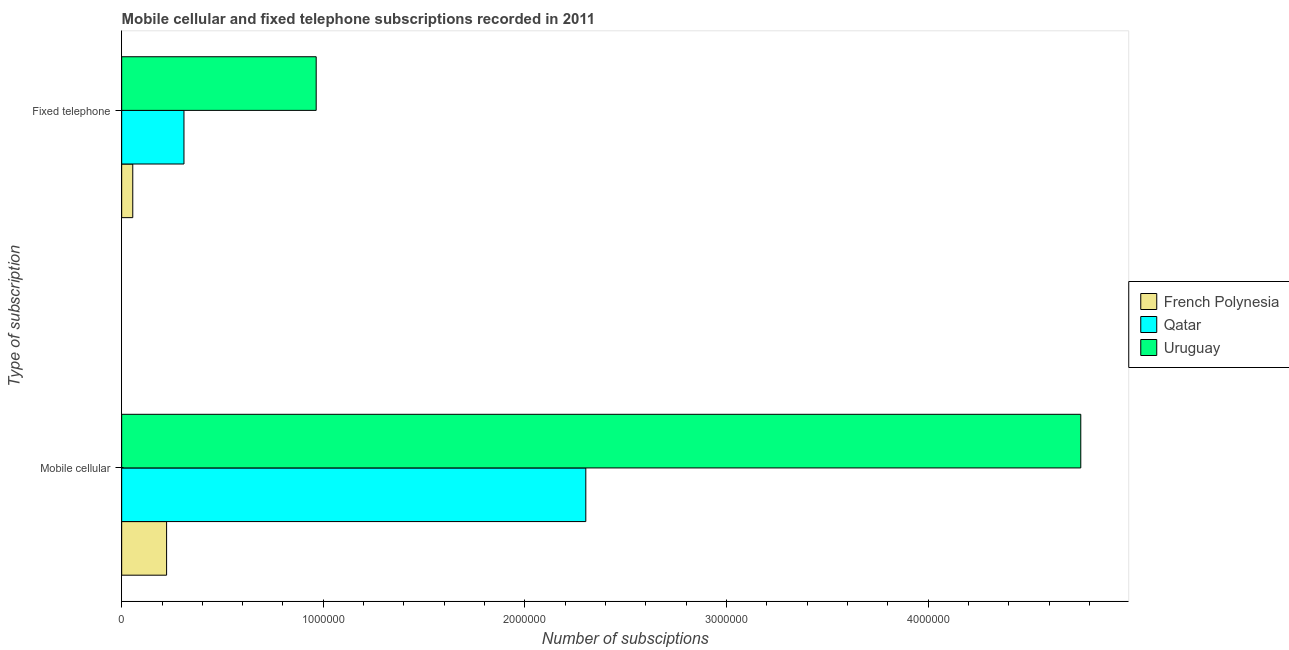How many different coloured bars are there?
Keep it short and to the point. 3. How many groups of bars are there?
Provide a short and direct response. 2. Are the number of bars per tick equal to the number of legend labels?
Provide a short and direct response. Yes. Are the number of bars on each tick of the Y-axis equal?
Offer a very short reply. Yes. How many bars are there on the 1st tick from the top?
Offer a terse response. 3. How many bars are there on the 1st tick from the bottom?
Ensure brevity in your answer.  3. What is the label of the 2nd group of bars from the top?
Your answer should be very brief. Mobile cellular. What is the number of fixed telephone subscriptions in French Polynesia?
Your answer should be compact. 5.50e+04. Across all countries, what is the maximum number of fixed telephone subscriptions?
Offer a terse response. 9.65e+05. Across all countries, what is the minimum number of fixed telephone subscriptions?
Offer a terse response. 5.50e+04. In which country was the number of fixed telephone subscriptions maximum?
Your response must be concise. Uruguay. In which country was the number of mobile cellular subscriptions minimum?
Ensure brevity in your answer.  French Polynesia. What is the total number of mobile cellular subscriptions in the graph?
Offer a terse response. 7.28e+06. What is the difference between the number of mobile cellular subscriptions in French Polynesia and that in Uruguay?
Give a very brief answer. -4.53e+06. What is the difference between the number of fixed telephone subscriptions in French Polynesia and the number of mobile cellular subscriptions in Uruguay?
Make the answer very short. -4.70e+06. What is the average number of fixed telephone subscriptions per country?
Provide a succinct answer. 4.43e+05. What is the difference between the number of mobile cellular subscriptions and number of fixed telephone subscriptions in Qatar?
Make the answer very short. 1.99e+06. In how many countries, is the number of fixed telephone subscriptions greater than 2400000 ?
Offer a very short reply. 0. What is the ratio of the number of fixed telephone subscriptions in French Polynesia to that in Uruguay?
Keep it short and to the point. 0.06. What does the 2nd bar from the top in Mobile cellular represents?
Provide a succinct answer. Qatar. What does the 2nd bar from the bottom in Fixed telephone represents?
Offer a terse response. Qatar. How many bars are there?
Provide a succinct answer. 6. Are the values on the major ticks of X-axis written in scientific E-notation?
Your response must be concise. No. Does the graph contain any zero values?
Give a very brief answer. No. Where does the legend appear in the graph?
Your response must be concise. Center right. How many legend labels are there?
Provide a succinct answer. 3. How are the legend labels stacked?
Your response must be concise. Vertical. What is the title of the graph?
Your response must be concise. Mobile cellular and fixed telephone subscriptions recorded in 2011. Does "Djibouti" appear as one of the legend labels in the graph?
Provide a short and direct response. No. What is the label or title of the X-axis?
Provide a succinct answer. Number of subsciptions. What is the label or title of the Y-axis?
Give a very brief answer. Type of subscription. What is the Number of subsciptions in French Polynesia in Mobile cellular?
Your answer should be very brief. 2.23e+05. What is the Number of subsciptions of Qatar in Mobile cellular?
Offer a very short reply. 2.30e+06. What is the Number of subsciptions of Uruguay in Mobile cellular?
Your answer should be very brief. 4.76e+06. What is the Number of subsciptions in French Polynesia in Fixed telephone?
Keep it short and to the point. 5.50e+04. What is the Number of subsciptions of Qatar in Fixed telephone?
Make the answer very short. 3.09e+05. What is the Number of subsciptions in Uruguay in Fixed telephone?
Offer a terse response. 9.65e+05. Across all Type of subscription, what is the maximum Number of subsciptions of French Polynesia?
Offer a very short reply. 2.23e+05. Across all Type of subscription, what is the maximum Number of subsciptions of Qatar?
Make the answer very short. 2.30e+06. Across all Type of subscription, what is the maximum Number of subsciptions of Uruguay?
Offer a terse response. 4.76e+06. Across all Type of subscription, what is the minimum Number of subsciptions of French Polynesia?
Your answer should be very brief. 5.50e+04. Across all Type of subscription, what is the minimum Number of subsciptions of Qatar?
Offer a terse response. 3.09e+05. Across all Type of subscription, what is the minimum Number of subsciptions in Uruguay?
Your response must be concise. 9.65e+05. What is the total Number of subsciptions in French Polynesia in the graph?
Your response must be concise. 2.78e+05. What is the total Number of subsciptions in Qatar in the graph?
Make the answer very short. 2.61e+06. What is the total Number of subsciptions in Uruguay in the graph?
Your answer should be very brief. 5.72e+06. What is the difference between the Number of subsciptions of French Polynesia in Mobile cellular and that in Fixed telephone?
Provide a short and direct response. 1.68e+05. What is the difference between the Number of subsciptions in Qatar in Mobile cellular and that in Fixed telephone?
Your response must be concise. 1.99e+06. What is the difference between the Number of subsciptions of Uruguay in Mobile cellular and that in Fixed telephone?
Make the answer very short. 3.79e+06. What is the difference between the Number of subsciptions of French Polynesia in Mobile cellular and the Number of subsciptions of Qatar in Fixed telephone?
Offer a very short reply. -8.62e+04. What is the difference between the Number of subsciptions of French Polynesia in Mobile cellular and the Number of subsciptions of Uruguay in Fixed telephone?
Keep it short and to the point. -7.42e+05. What is the difference between the Number of subsciptions in Qatar in Mobile cellular and the Number of subsciptions in Uruguay in Fixed telephone?
Provide a short and direct response. 1.34e+06. What is the average Number of subsciptions in French Polynesia per Type of subscription?
Make the answer very short. 1.39e+05. What is the average Number of subsciptions in Qatar per Type of subscription?
Provide a short and direct response. 1.31e+06. What is the average Number of subsciptions of Uruguay per Type of subscription?
Provide a short and direct response. 2.86e+06. What is the difference between the Number of subsciptions of French Polynesia and Number of subsciptions of Qatar in Mobile cellular?
Your response must be concise. -2.08e+06. What is the difference between the Number of subsciptions of French Polynesia and Number of subsciptions of Uruguay in Mobile cellular?
Offer a very short reply. -4.53e+06. What is the difference between the Number of subsciptions in Qatar and Number of subsciptions in Uruguay in Mobile cellular?
Ensure brevity in your answer.  -2.46e+06. What is the difference between the Number of subsciptions in French Polynesia and Number of subsciptions in Qatar in Fixed telephone?
Make the answer very short. -2.54e+05. What is the difference between the Number of subsciptions in French Polynesia and Number of subsciptions in Uruguay in Fixed telephone?
Ensure brevity in your answer.  -9.10e+05. What is the difference between the Number of subsciptions in Qatar and Number of subsciptions in Uruguay in Fixed telephone?
Offer a terse response. -6.56e+05. What is the ratio of the Number of subsciptions in French Polynesia in Mobile cellular to that in Fixed telephone?
Keep it short and to the point. 4.05. What is the ratio of the Number of subsciptions of Qatar in Mobile cellular to that in Fixed telephone?
Offer a very short reply. 7.45. What is the ratio of the Number of subsciptions in Uruguay in Mobile cellular to that in Fixed telephone?
Offer a terse response. 4.93. What is the difference between the highest and the second highest Number of subsciptions in French Polynesia?
Provide a short and direct response. 1.68e+05. What is the difference between the highest and the second highest Number of subsciptions in Qatar?
Keep it short and to the point. 1.99e+06. What is the difference between the highest and the second highest Number of subsciptions in Uruguay?
Provide a short and direct response. 3.79e+06. What is the difference between the highest and the lowest Number of subsciptions in French Polynesia?
Offer a very short reply. 1.68e+05. What is the difference between the highest and the lowest Number of subsciptions of Qatar?
Your answer should be very brief. 1.99e+06. What is the difference between the highest and the lowest Number of subsciptions of Uruguay?
Provide a short and direct response. 3.79e+06. 